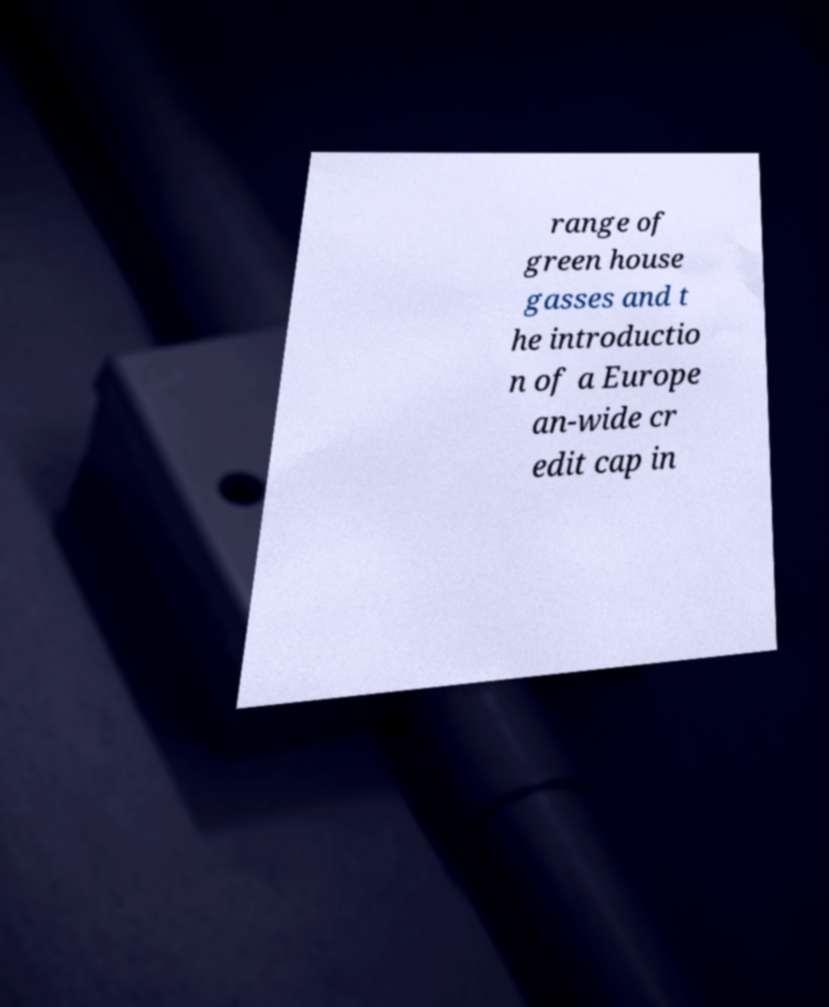Could you assist in decoding the text presented in this image and type it out clearly? range of green house gasses and t he introductio n of a Europe an-wide cr edit cap in 